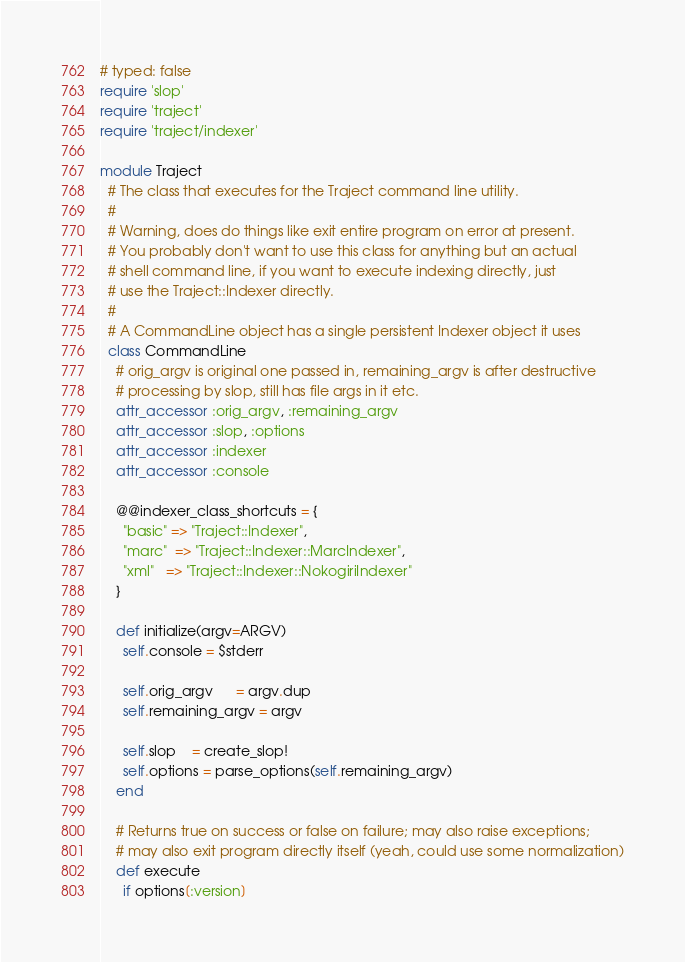Convert code to text. <code><loc_0><loc_0><loc_500><loc_500><_Ruby_># typed: false
require 'slop'
require 'traject'
require 'traject/indexer'

module Traject
  # The class that executes for the Traject command line utility.
  #
  # Warning, does do things like exit entire program on error at present.
  # You probably don't want to use this class for anything but an actual
  # shell command line, if you want to execute indexing directly, just
  # use the Traject::Indexer directly.
  #
  # A CommandLine object has a single persistent Indexer object it uses
  class CommandLine
    # orig_argv is original one passed in, remaining_argv is after destructive
    # processing by slop, still has file args in it etc.
    attr_accessor :orig_argv, :remaining_argv
    attr_accessor :slop, :options
    attr_accessor :indexer
    attr_accessor :console

    @@indexer_class_shortcuts = {
      "basic" => "Traject::Indexer",
      "marc"  => "Traject::Indexer::MarcIndexer",
      "xml"   => "Traject::Indexer::NokogiriIndexer"
    }

    def initialize(argv=ARGV)
      self.console = $stderr

      self.orig_argv      = argv.dup
      self.remaining_argv = argv

      self.slop    = create_slop!
      self.options = parse_options(self.remaining_argv)
    end

    # Returns true on success or false on failure; may also raise exceptions;
    # may also exit program directly itself (yeah, could use some normalization)
    def execute
      if options[:version]</code> 